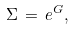Convert formula to latex. <formula><loc_0><loc_0><loc_500><loc_500>\Sigma \, = \, e ^ { G } ,</formula> 